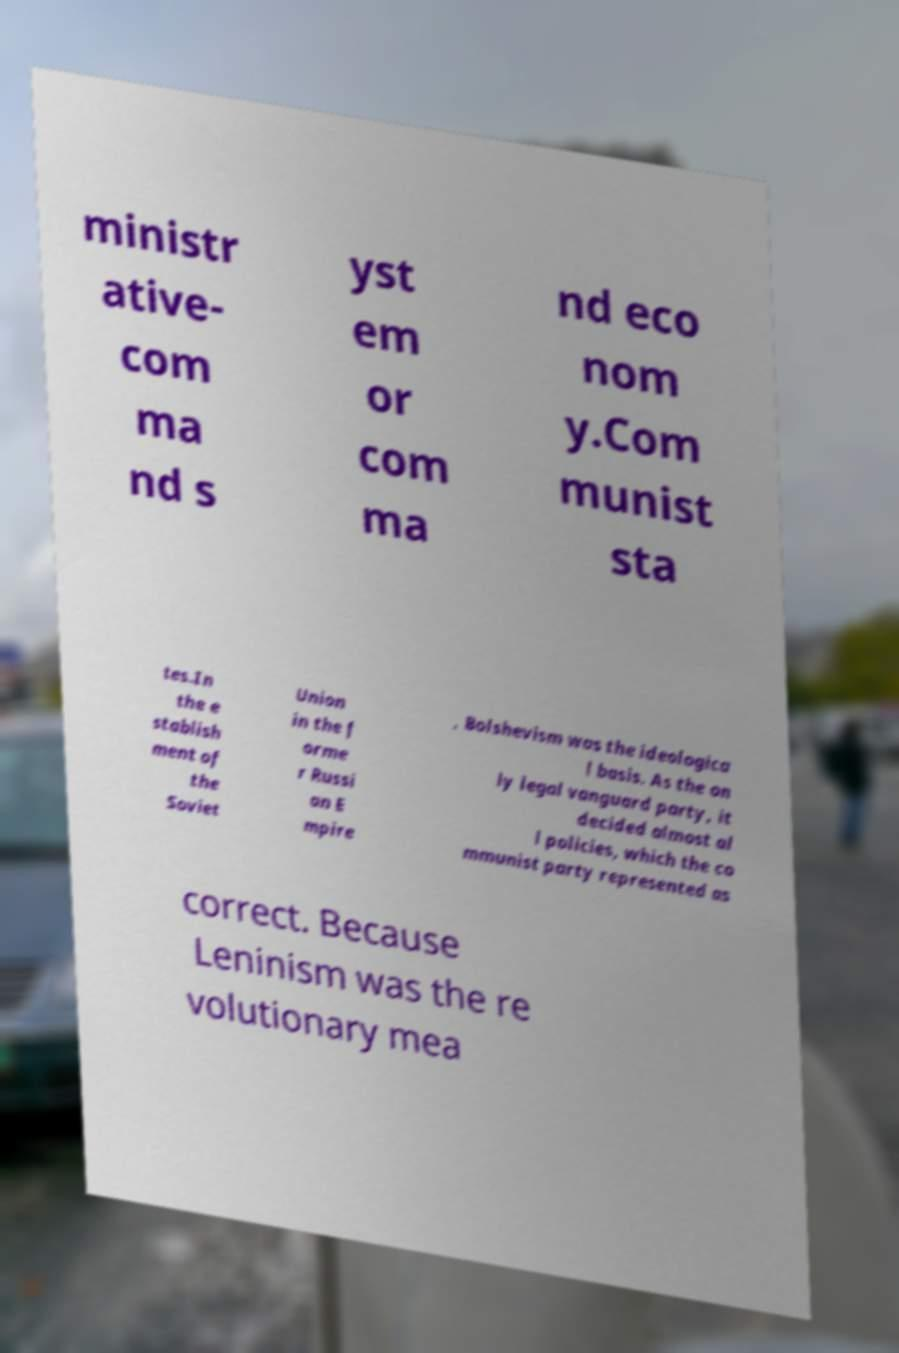Please read and relay the text visible in this image. What does it say? ministr ative- com ma nd s yst em or com ma nd eco nom y.Com munist sta tes.In the e stablish ment of the Soviet Union in the f orme r Russi an E mpire , Bolshevism was the ideologica l basis. As the on ly legal vanguard party, it decided almost al l policies, which the co mmunist party represented as correct. Because Leninism was the re volutionary mea 